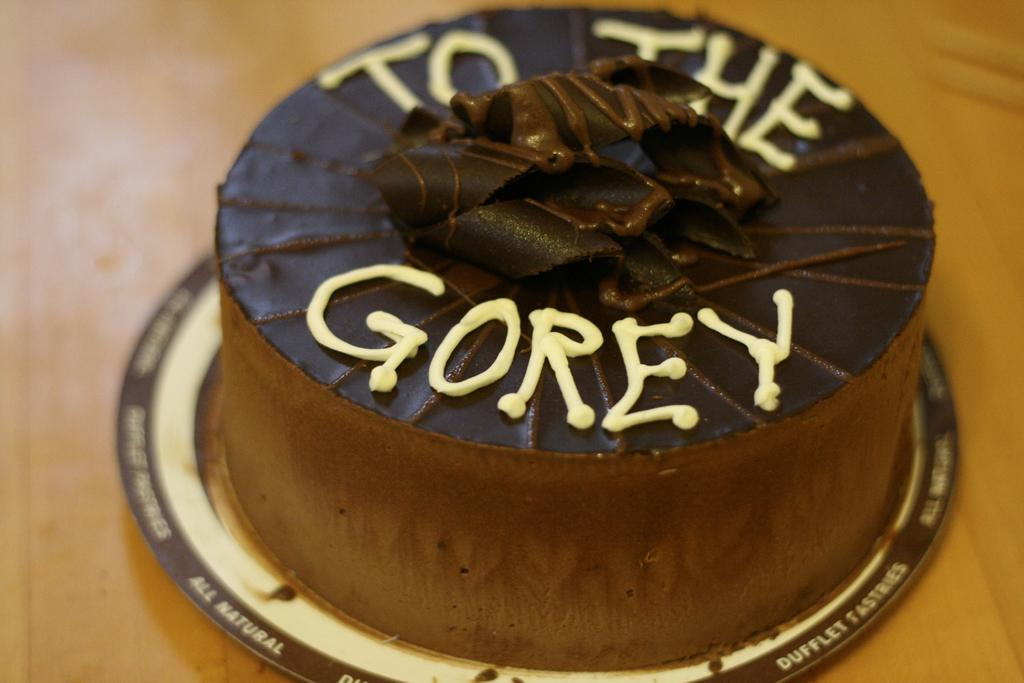What is the main object on the tray in the image? There is a cake on a tray in the image. What type of furniture is present in the image? There is a table in the image. What type of oil is being used to lubricate the cake in the image? There is no oil or lubrication involved with the cake in the image. 